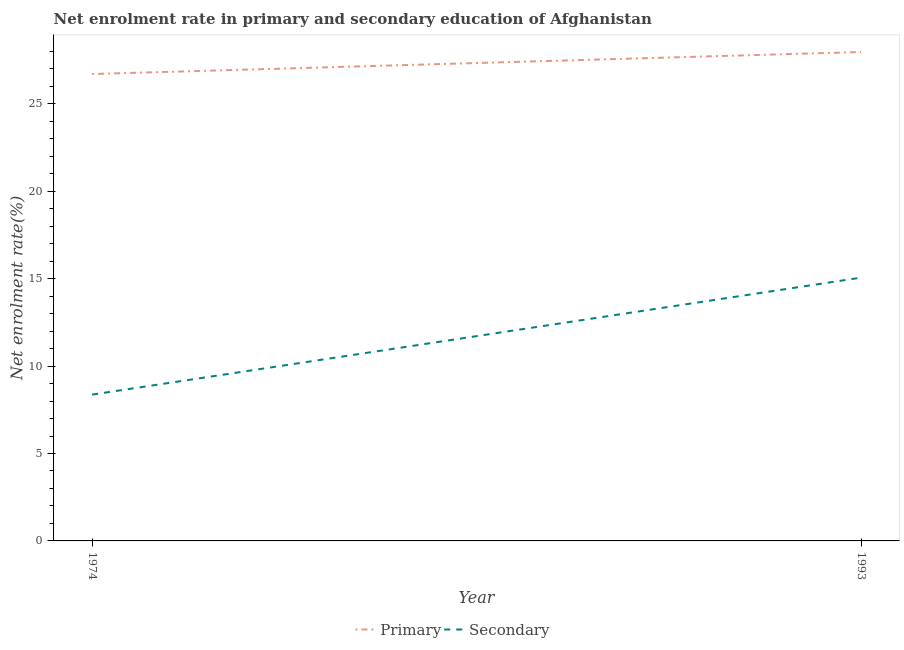How many different coloured lines are there?
Provide a short and direct response. 2. Does the line corresponding to enrollment rate in primary education intersect with the line corresponding to enrollment rate in secondary education?
Your response must be concise. No. What is the enrollment rate in secondary education in 1974?
Ensure brevity in your answer.  8.37. Across all years, what is the maximum enrollment rate in primary education?
Your answer should be compact. 27.96. Across all years, what is the minimum enrollment rate in secondary education?
Ensure brevity in your answer.  8.37. In which year was the enrollment rate in primary education minimum?
Ensure brevity in your answer.  1974. What is the total enrollment rate in secondary education in the graph?
Ensure brevity in your answer.  23.42. What is the difference between the enrollment rate in primary education in 1974 and that in 1993?
Provide a succinct answer. -1.26. What is the difference between the enrollment rate in primary education in 1974 and the enrollment rate in secondary education in 1993?
Your answer should be very brief. 11.64. What is the average enrollment rate in secondary education per year?
Give a very brief answer. 11.71. In the year 1974, what is the difference between the enrollment rate in primary education and enrollment rate in secondary education?
Offer a very short reply. 18.33. In how many years, is the enrollment rate in primary education greater than 11 %?
Keep it short and to the point. 2. What is the ratio of the enrollment rate in secondary education in 1974 to that in 1993?
Your answer should be compact. 0.56. Is the enrollment rate in secondary education in 1974 less than that in 1993?
Provide a short and direct response. Yes. In how many years, is the enrollment rate in primary education greater than the average enrollment rate in primary education taken over all years?
Make the answer very short. 1. Is the enrollment rate in secondary education strictly greater than the enrollment rate in primary education over the years?
Ensure brevity in your answer.  No. How many lines are there?
Give a very brief answer. 2. How many years are there in the graph?
Offer a very short reply. 2. Does the graph contain grids?
Your answer should be compact. No. Where does the legend appear in the graph?
Ensure brevity in your answer.  Bottom center. What is the title of the graph?
Offer a terse response. Net enrolment rate in primary and secondary education of Afghanistan. What is the label or title of the Y-axis?
Your response must be concise. Net enrolment rate(%). What is the Net enrolment rate(%) in Primary in 1974?
Provide a short and direct response. 26.7. What is the Net enrolment rate(%) in Secondary in 1974?
Provide a short and direct response. 8.37. What is the Net enrolment rate(%) of Primary in 1993?
Provide a short and direct response. 27.96. What is the Net enrolment rate(%) in Secondary in 1993?
Offer a very short reply. 15.06. Across all years, what is the maximum Net enrolment rate(%) in Primary?
Provide a short and direct response. 27.96. Across all years, what is the maximum Net enrolment rate(%) in Secondary?
Ensure brevity in your answer.  15.06. Across all years, what is the minimum Net enrolment rate(%) of Primary?
Offer a very short reply. 26.7. Across all years, what is the minimum Net enrolment rate(%) of Secondary?
Your answer should be very brief. 8.37. What is the total Net enrolment rate(%) of Primary in the graph?
Provide a succinct answer. 54.66. What is the total Net enrolment rate(%) in Secondary in the graph?
Give a very brief answer. 23.42. What is the difference between the Net enrolment rate(%) of Primary in 1974 and that in 1993?
Provide a short and direct response. -1.26. What is the difference between the Net enrolment rate(%) in Secondary in 1974 and that in 1993?
Keep it short and to the point. -6.69. What is the difference between the Net enrolment rate(%) in Primary in 1974 and the Net enrolment rate(%) in Secondary in 1993?
Your response must be concise. 11.64. What is the average Net enrolment rate(%) of Primary per year?
Your answer should be very brief. 27.33. What is the average Net enrolment rate(%) of Secondary per year?
Provide a short and direct response. 11.71. In the year 1974, what is the difference between the Net enrolment rate(%) of Primary and Net enrolment rate(%) of Secondary?
Offer a very short reply. 18.33. In the year 1993, what is the difference between the Net enrolment rate(%) in Primary and Net enrolment rate(%) in Secondary?
Offer a terse response. 12.9. What is the ratio of the Net enrolment rate(%) of Primary in 1974 to that in 1993?
Provide a short and direct response. 0.95. What is the ratio of the Net enrolment rate(%) of Secondary in 1974 to that in 1993?
Your answer should be very brief. 0.56. What is the difference between the highest and the second highest Net enrolment rate(%) in Primary?
Your response must be concise. 1.26. What is the difference between the highest and the second highest Net enrolment rate(%) in Secondary?
Provide a short and direct response. 6.69. What is the difference between the highest and the lowest Net enrolment rate(%) in Primary?
Your response must be concise. 1.26. What is the difference between the highest and the lowest Net enrolment rate(%) in Secondary?
Your answer should be very brief. 6.69. 